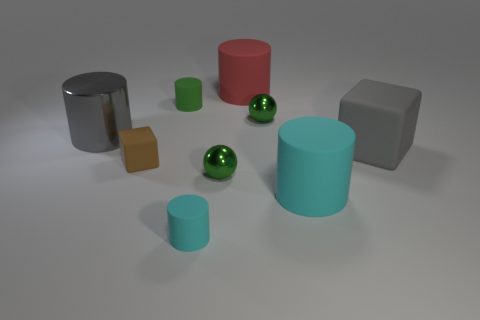Is the material of the tiny green cylinder the same as the large cylinder that is right of the big red rubber object?
Provide a short and direct response. Yes. There is another matte thing that is the same shape as the small brown rubber thing; what size is it?
Your answer should be very brief. Large. What material is the large cube?
Your answer should be compact. Rubber. What material is the tiny ball in front of the rubber cube right of the block on the left side of the gray cube?
Keep it short and to the point. Metal. There is a green metallic sphere behind the gray shiny thing; is its size the same as the metal sphere in front of the small rubber cube?
Make the answer very short. Yes. How many other objects are the same material as the big gray block?
Keep it short and to the point. 5. What number of metal objects are either brown things or big gray blocks?
Make the answer very short. 0. Are there fewer tiny cyan rubber things than tiny green rubber balls?
Your answer should be very brief. No. Do the red matte cylinder and the brown thing left of the tiny green matte cylinder have the same size?
Ensure brevity in your answer.  No. Are there any other things that have the same shape as the tiny brown thing?
Your answer should be very brief. Yes. 